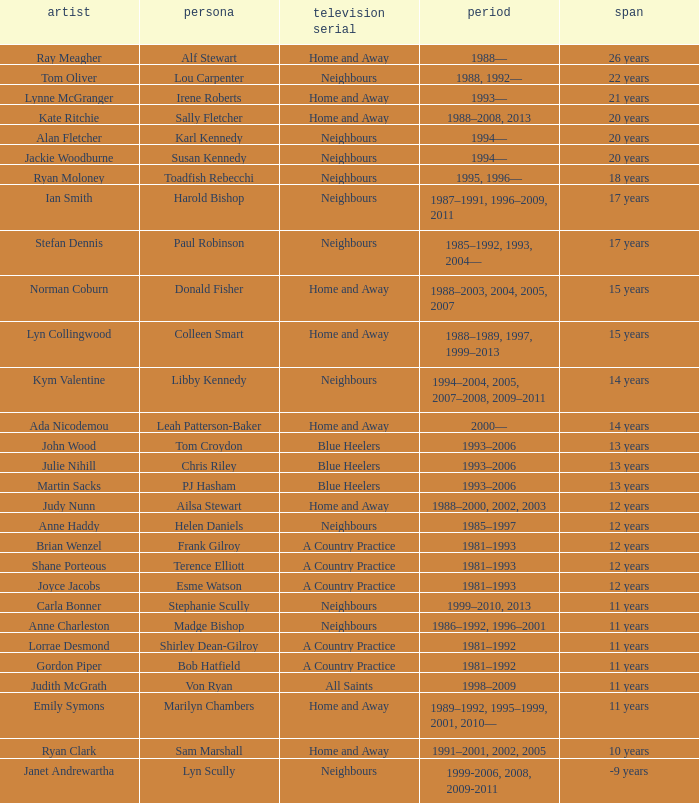Which actor played on Home and Away for 20 years? Kate Ritchie. Would you mind parsing the complete table? {'header': ['artist', 'persona', 'television serial', 'period', 'span'], 'rows': [['Ray Meagher', 'Alf Stewart', 'Home and Away', '1988—', '26 years'], ['Tom Oliver', 'Lou Carpenter', 'Neighbours', '1988, 1992—', '22 years'], ['Lynne McGranger', 'Irene Roberts', 'Home and Away', '1993—', '21 years'], ['Kate Ritchie', 'Sally Fletcher', 'Home and Away', '1988–2008, 2013', '20 years'], ['Alan Fletcher', 'Karl Kennedy', 'Neighbours', '1994—', '20 years'], ['Jackie Woodburne', 'Susan Kennedy', 'Neighbours', '1994—', '20 years'], ['Ryan Moloney', 'Toadfish Rebecchi', 'Neighbours', '1995, 1996—', '18 years'], ['Ian Smith', 'Harold Bishop', 'Neighbours', '1987–1991, 1996–2009, 2011', '17 years'], ['Stefan Dennis', 'Paul Robinson', 'Neighbours', '1985–1992, 1993, 2004—', '17 years'], ['Norman Coburn', 'Donald Fisher', 'Home and Away', '1988–2003, 2004, 2005, 2007', '15 years'], ['Lyn Collingwood', 'Colleen Smart', 'Home and Away', '1988–1989, 1997, 1999–2013', '15 years'], ['Kym Valentine', 'Libby Kennedy', 'Neighbours', '1994–2004, 2005, 2007–2008, 2009–2011', '14 years'], ['Ada Nicodemou', 'Leah Patterson-Baker', 'Home and Away', '2000—', '14 years'], ['John Wood', 'Tom Croydon', 'Blue Heelers', '1993–2006', '13 years'], ['Julie Nihill', 'Chris Riley', 'Blue Heelers', '1993–2006', '13 years'], ['Martin Sacks', 'PJ Hasham', 'Blue Heelers', '1993–2006', '13 years'], ['Judy Nunn', 'Ailsa Stewart', 'Home and Away', '1988–2000, 2002, 2003', '12 years'], ['Anne Haddy', 'Helen Daniels', 'Neighbours', '1985–1997', '12 years'], ['Brian Wenzel', 'Frank Gilroy', 'A Country Practice', '1981–1993', '12 years'], ['Shane Porteous', 'Terence Elliott', 'A Country Practice', '1981–1993', '12 years'], ['Joyce Jacobs', 'Esme Watson', 'A Country Practice', '1981–1993', '12 years'], ['Carla Bonner', 'Stephanie Scully', 'Neighbours', '1999–2010, 2013', '11 years'], ['Anne Charleston', 'Madge Bishop', 'Neighbours', '1986–1992, 1996–2001', '11 years'], ['Lorrae Desmond', 'Shirley Dean-Gilroy', 'A Country Practice', '1981–1992', '11 years'], ['Gordon Piper', 'Bob Hatfield', 'A Country Practice', '1981–1992', '11 years'], ['Judith McGrath', 'Von Ryan', 'All Saints', '1998–2009', '11 years'], ['Emily Symons', 'Marilyn Chambers', 'Home and Away', '1989–1992, 1995–1999, 2001, 2010—', '11 years'], ['Ryan Clark', 'Sam Marshall', 'Home and Away', '1991–2001, 2002, 2005', '10 years'], ['Janet Andrewartha', 'Lyn Scully', 'Neighbours', '1999-2006, 2008, 2009-2011', '-9 years']]} 